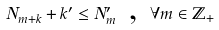<formula> <loc_0><loc_0><loc_500><loc_500>N _ { m + k } + k ^ { \prime } \leq N _ { m } ^ { \prime } \text { , } \forall m \in \mathbb { Z } _ { + }</formula> 